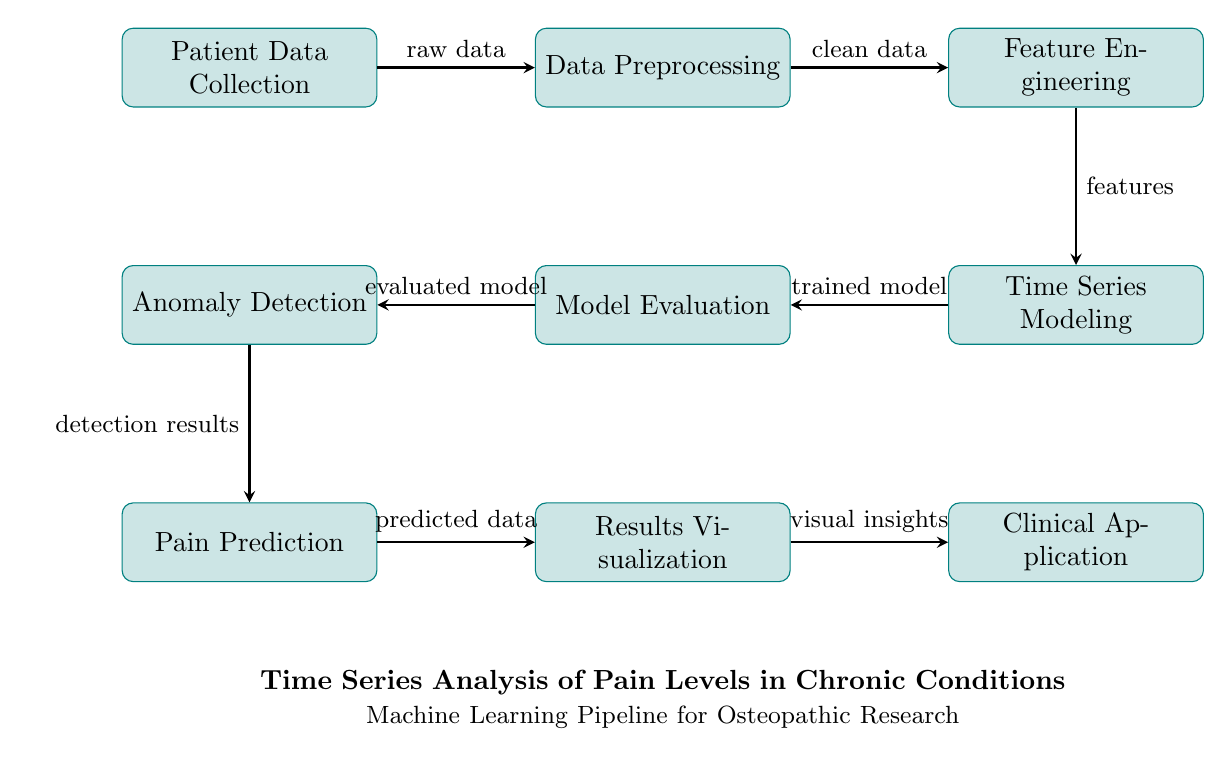What is the first process in the diagram? The diagram shows "Patient Data Collection" as the first node, indicating it is the starting point of the machine learning pipeline.
Answer: Patient Data Collection How many nodes are in the diagram? By counting each labeled rectangle in the diagram, there are a total of eight nodes present, each representing a distinct process in the analysis.
Answer: Eight What follows Data Preprocessing in the pipeline? The diagram indicates that the next step after "Data Preprocessing" is "Feature Engineering," which means the transition occurs after cleaning the data.
Answer: Feature Engineering Which process is directly after Model Evaluation? According to the arrows in the diagram, the process that directly follows "Model Evaluation" is "Anomaly Detection," showing the flow of the machine learning pipeline.
Answer: Anomaly Detection What type of data is resulting from Pain Prediction? The diagram states that "Pain Prediction" results in "predicted data," indicating that this stage generates the output for further analysis.
Answer: Predicted data Which process provides visual insights? From the diagram, "Results Visualization" is identified as the process that generates "visual insights" based on the predicted data.
Answer: Results Visualization Which two processes are parallel in the diagram? "Time Series Modeling" and "Pain Prediction" run in parallel, as indicated in the diagram, representing related activities in the machine learning flow.
Answer: Time Series Modeling and Pain Prediction What type of insights does the final node provide? The diagram shows that the final process, "Clinical Application," delivers "clinical application," which summarizes the insights obtained from the preceding analysis stages.
Answer: Clinical Application What is the output of the Anomaly Detection process? The flow from "Anomaly Detection" to "Pain Prediction" shows that the output is "detection results," which feed into the next stage of the analysis.
Answer: Detection results 